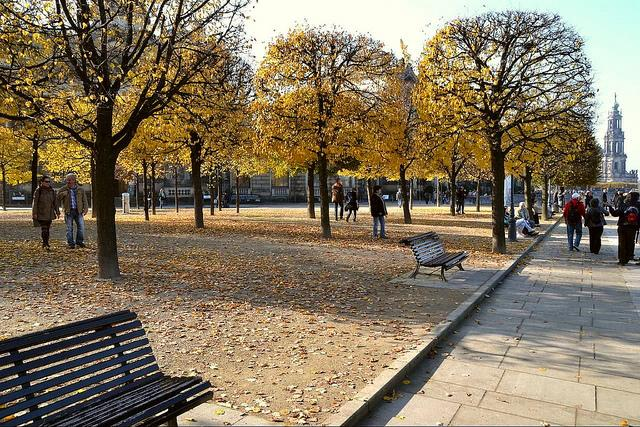How many months till the leaves turn green? six 